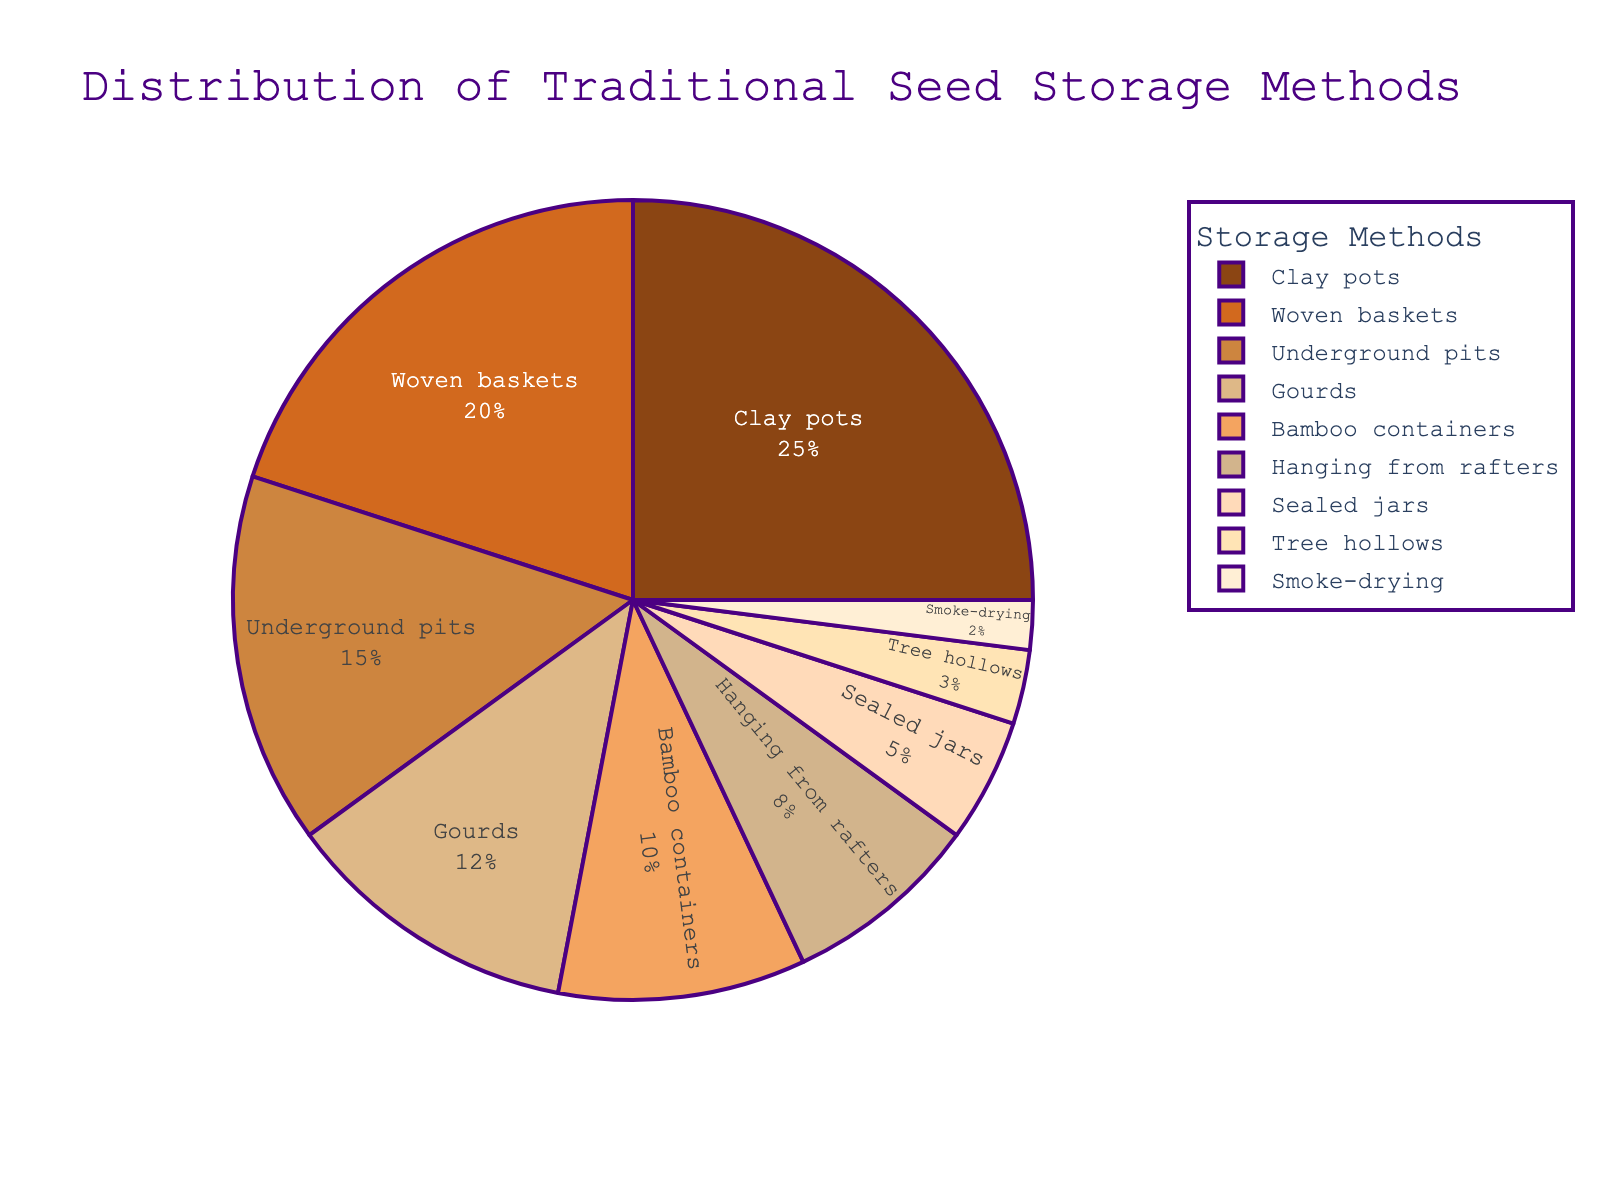Which seed storage method holds the highest percentage? Locate the segment with the largest size in the pie chart. The label "Clay pots" is associated with the largest segment. Since its percentage is 25%, it holds the highest percentage.
Answer: Clay pots Which two seed storage methods have a combined percentage higher than that of woven baskets? Identify "Woven baskets" on the pie chart, which has a percentage of 20%. Now find any two methods that have a combined percentage greater than 20%. "Underground pits" (15%) and "Gourds" (12%) combined have 27%, which is greater than 20%.
Answer: Underground pits and Gourds Is the percentage of bamboo containers greater than that of smoke-drying? Locate both "Bamboo containers" and "Smoke-drying" on the pie chart. "Bamboo containers" have a percentage of 10%, while "Smoke-drying" has 2%. Since 10% is greater than 2%, "Bamboo containers" have a greater percentage.
Answer: Yes What is the total percentage of seed storage methods occupying more than 10% each? Identify the segments with more than 10%: "Clay pots" (25%), "Woven baskets" (20%), "Underground pits" (15%), and "Gourds" (12%). Summing these percentages gives 25% + 20% + 15% + 12% = 72%.
Answer: 72% Which seed storage method has a lower percentage than tree hollows? Observe the "Tree hollows" segment having a percentage of 3%. "Smoke-drying", which has 2%, is the only method with a lower percentage.
Answer: Smoke-drying How much higher is the percentage of hanging from rafters compared to sealed jars? Find the percentages for "Hanging from rafters" (8%) and "Sealed jars" (5%). Subtract the latter from the former: 8% - 5% = 3%. Thus, the percentage is 3% higher.
Answer: 3% Are there more methods with a percentage below 10% or above 10%? Identify methods below 10%: "Bamboo containers" (10%), "Hanging from rafters" (8%), "Sealed jars" (5%), "Tree hollows" (3%), and "Smoke-drying" (2%). There are five methods below 10%. Those above 10%: "Clay pots" (25%), "Woven baskets" (20%), "Underground pits" (15%), and "Gourds" (12%) make four methods above 10%. Therefore, there are more methods below 10%.
Answer: Below 10% What is the average percentage of the methods that make up the smallest three segments? Identify the smallest three segments: "Smoke-drying" (2%), "Tree hollows" (3%), and "Sealed jars" (5%). The sum is 2% + 3% + 5% = 10%. Calculate the average by dividing by 3: 10% / 3 ≈ 3.33%.
Answer: 3.33% 